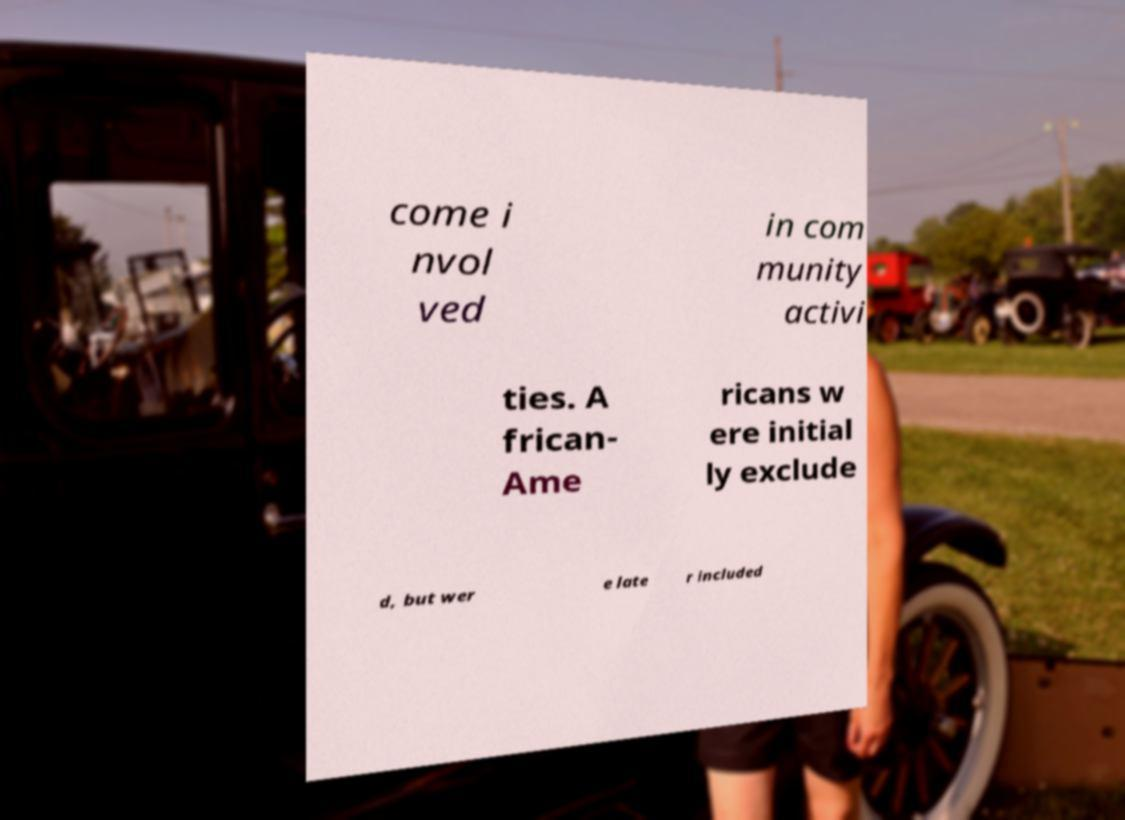Please read and relay the text visible in this image. What does it say? come i nvol ved in com munity activi ties. A frican- Ame ricans w ere initial ly exclude d, but wer e late r included 